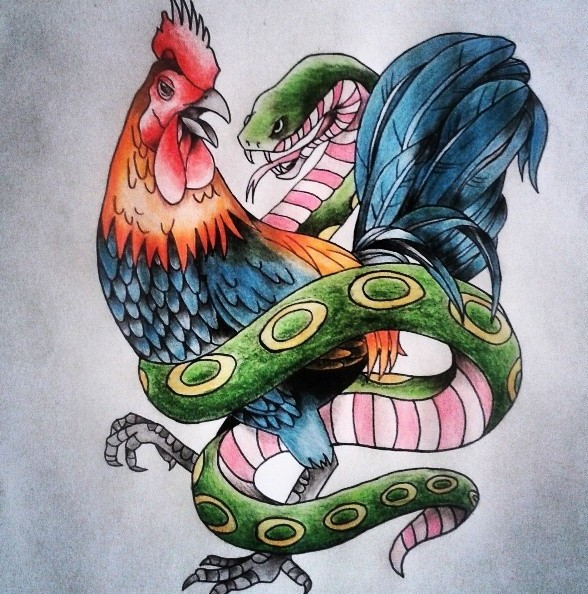Considering the symbolic meanings often associated with animals in art and literature, what might the intertwining of the rooster and snake in this illustration represent, and why would these particular animals be chosen to convey such a message? In various cultures, the rooster and the snake carry rich and contrasting symbolism. The rooster is often seen as a symbol of awakening, vigilance, and courage, rising every morning to herald the dawn. On the other hand, the snake can embody duality—wisdom and temptation, or rebirth and healing, largely due to its cyclical shedding of skin. The intertwining of these two animals might represent the age-old struggle between contrasting forces or principles: light versus darkness, wisdom versus folly, and life versus death. By choosing these particular animals, the artist could be creating a powerful visual metaphor for balance and conflict between these dualistic concepts, inviting viewers to explore the tension and harmony present in the natural and spiritual worlds. 